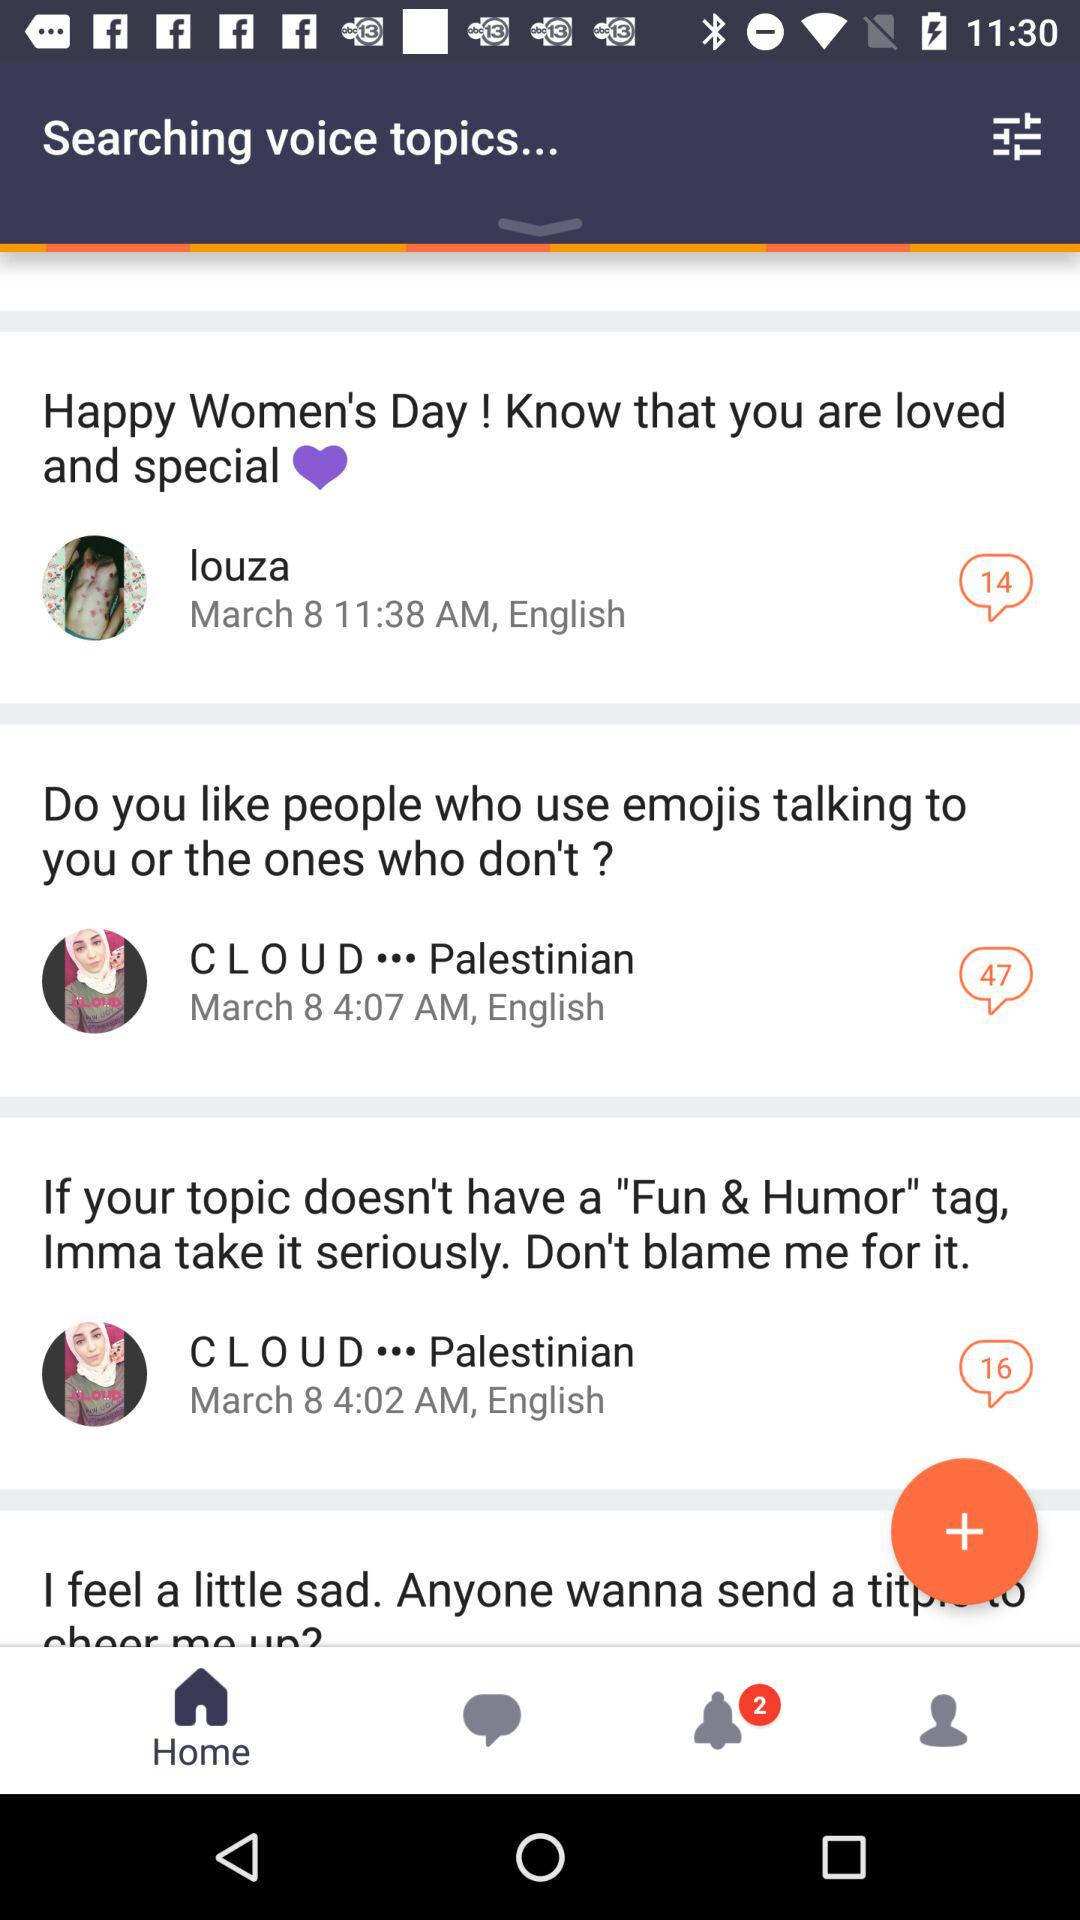Are there any unread notifications? There are 2 unread notifications. 